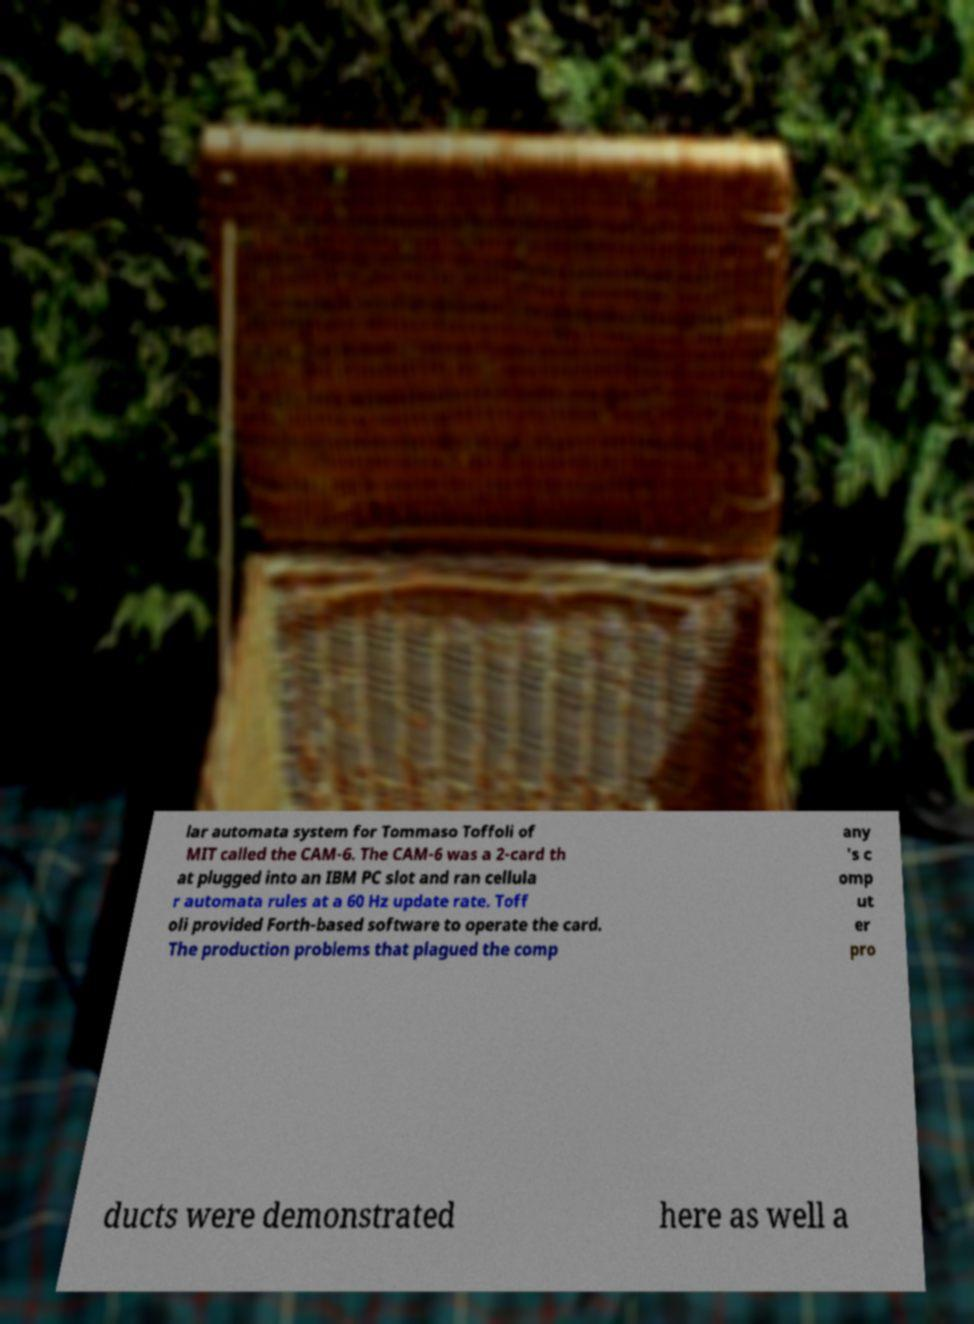For documentation purposes, I need the text within this image transcribed. Could you provide that? lar automata system for Tommaso Toffoli of MIT called the CAM-6. The CAM-6 was a 2-card th at plugged into an IBM PC slot and ran cellula r automata rules at a 60 Hz update rate. Toff oli provided Forth-based software to operate the card. The production problems that plagued the comp any 's c omp ut er pro ducts were demonstrated here as well a 